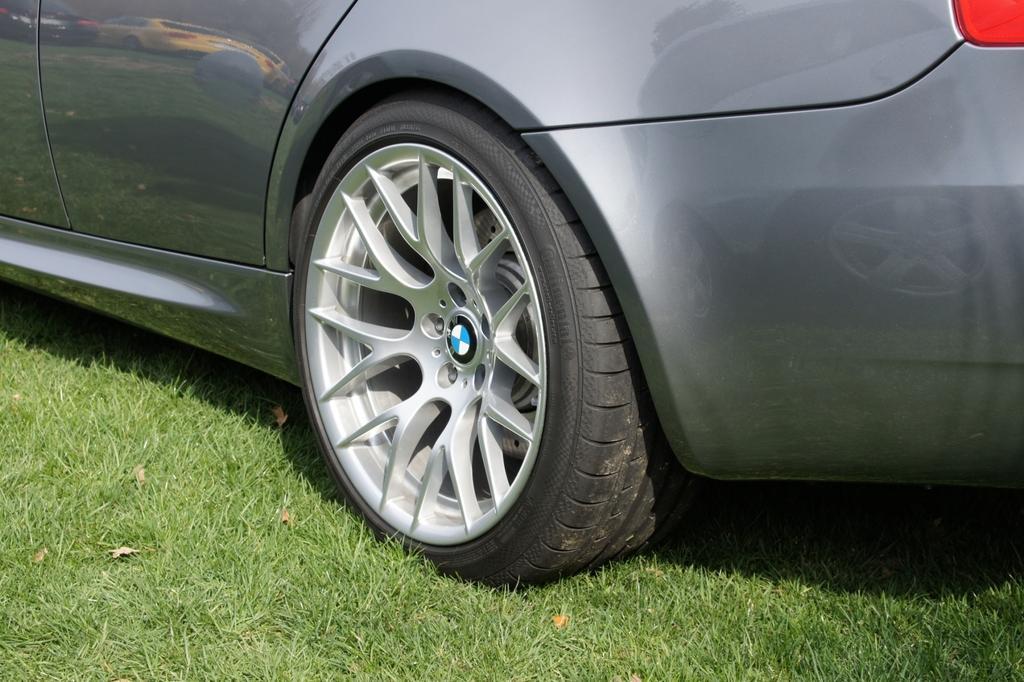Describe this image in one or two sentences. In this image we can see a car parked on the ground. 